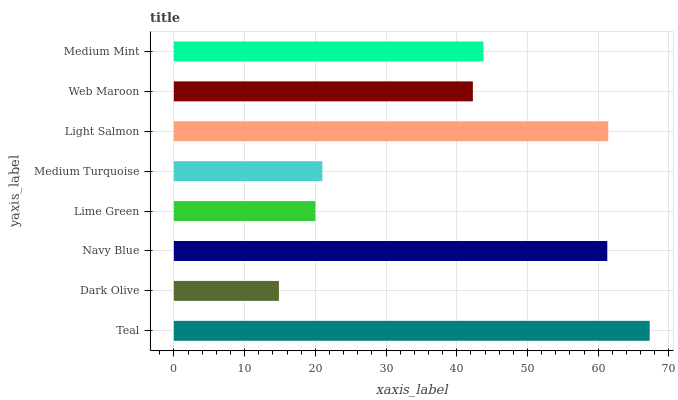Is Dark Olive the minimum?
Answer yes or no. Yes. Is Teal the maximum?
Answer yes or no. Yes. Is Navy Blue the minimum?
Answer yes or no. No. Is Navy Blue the maximum?
Answer yes or no. No. Is Navy Blue greater than Dark Olive?
Answer yes or no. Yes. Is Dark Olive less than Navy Blue?
Answer yes or no. Yes. Is Dark Olive greater than Navy Blue?
Answer yes or no. No. Is Navy Blue less than Dark Olive?
Answer yes or no. No. Is Medium Mint the high median?
Answer yes or no. Yes. Is Web Maroon the low median?
Answer yes or no. Yes. Is Dark Olive the high median?
Answer yes or no. No. Is Light Salmon the low median?
Answer yes or no. No. 